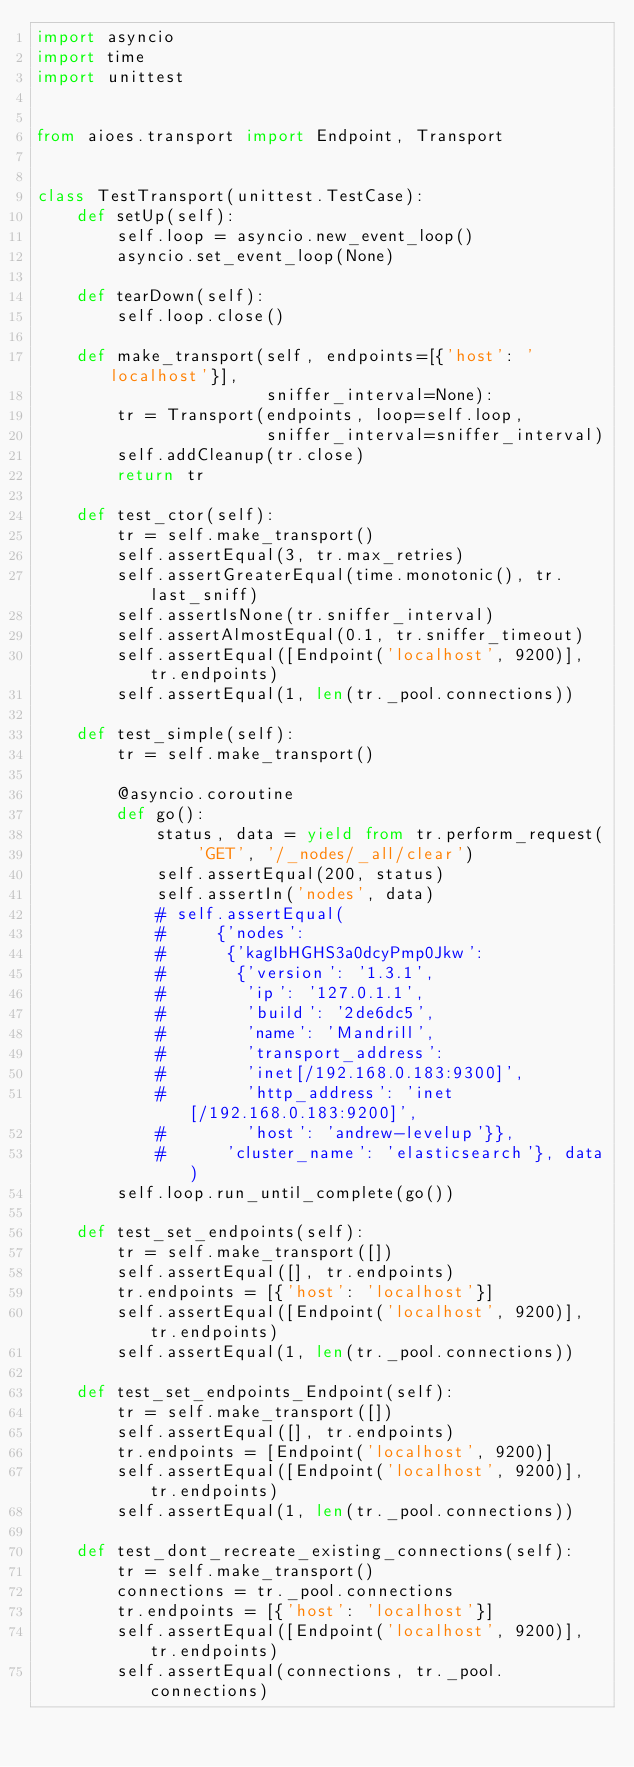<code> <loc_0><loc_0><loc_500><loc_500><_Python_>import asyncio
import time
import unittest


from aioes.transport import Endpoint, Transport


class TestTransport(unittest.TestCase):
    def setUp(self):
        self.loop = asyncio.new_event_loop()
        asyncio.set_event_loop(None)

    def tearDown(self):
        self.loop.close()

    def make_transport(self, endpoints=[{'host': 'localhost'}],
                       sniffer_interval=None):
        tr = Transport(endpoints, loop=self.loop,
                       sniffer_interval=sniffer_interval)
        self.addCleanup(tr.close)
        return tr

    def test_ctor(self):
        tr = self.make_transport()
        self.assertEqual(3, tr.max_retries)
        self.assertGreaterEqual(time.monotonic(), tr.last_sniff)
        self.assertIsNone(tr.sniffer_interval)
        self.assertAlmostEqual(0.1, tr.sniffer_timeout)
        self.assertEqual([Endpoint('localhost', 9200)], tr.endpoints)
        self.assertEqual(1, len(tr._pool.connections))

    def test_simple(self):
        tr = self.make_transport()

        @asyncio.coroutine
        def go():
            status, data = yield from tr.perform_request(
                'GET', '/_nodes/_all/clear')
            self.assertEqual(200, status)
            self.assertIn('nodes', data)
            # self.assertEqual(
            #     {'nodes':
            #      {'kagIbHGHS3a0dcyPmp0Jkw':
            #       {'version': '1.3.1',
            #        'ip': '127.0.1.1',
            #        'build': '2de6dc5',
            #        'name': 'Mandrill',
            #        'transport_address':
            #        'inet[/192.168.0.183:9300]',
            #        'http_address': 'inet[/192.168.0.183:9200]',
            #        'host': 'andrew-levelup'}},
            #      'cluster_name': 'elasticsearch'}, data)
        self.loop.run_until_complete(go())

    def test_set_endpoints(self):
        tr = self.make_transport([])
        self.assertEqual([], tr.endpoints)
        tr.endpoints = [{'host': 'localhost'}]
        self.assertEqual([Endpoint('localhost', 9200)], tr.endpoints)
        self.assertEqual(1, len(tr._pool.connections))

    def test_set_endpoints_Endpoint(self):
        tr = self.make_transport([])
        self.assertEqual([], tr.endpoints)
        tr.endpoints = [Endpoint('localhost', 9200)]
        self.assertEqual([Endpoint('localhost', 9200)], tr.endpoints)
        self.assertEqual(1, len(tr._pool.connections))

    def test_dont_recreate_existing_connections(self):
        tr = self.make_transport()
        connections = tr._pool.connections
        tr.endpoints = [{'host': 'localhost'}]
        self.assertEqual([Endpoint('localhost', 9200)], tr.endpoints)
        self.assertEqual(connections, tr._pool.connections)
</code> 